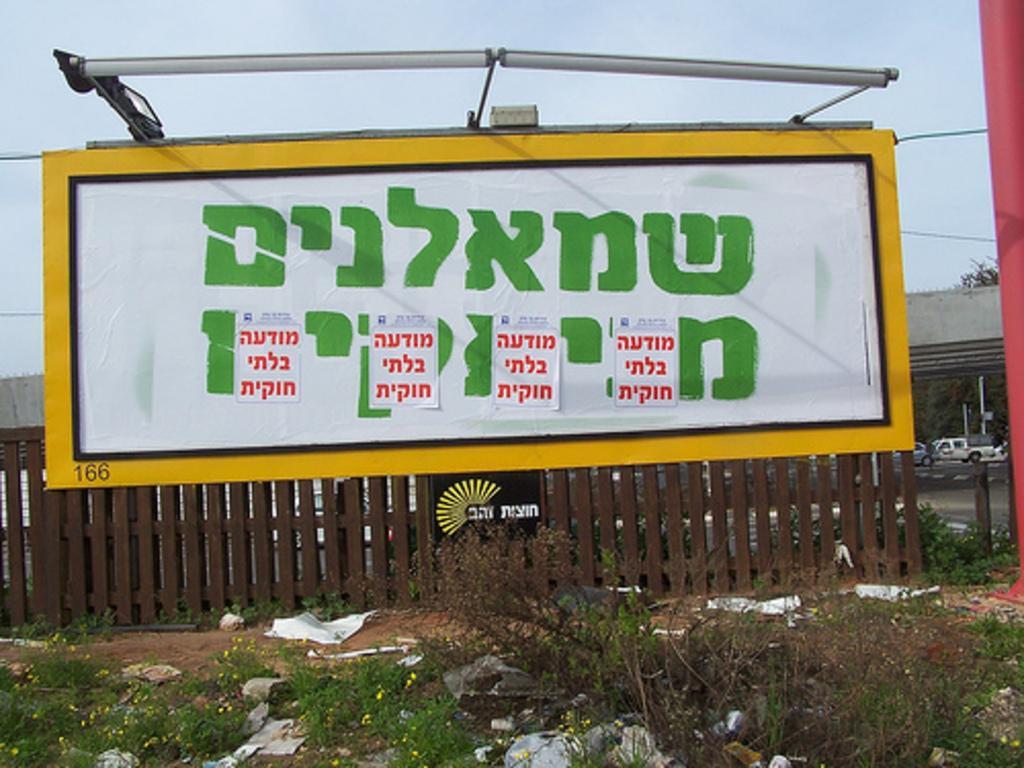Can you describe this image briefly? In this image in the front there's grass on the ground and in the center there is a fence. On the top of the fence there is a banner with some text written on it. In the background there are vehicles and there is a wall and there are trees. On the right side there is a pole which is red in colour. 